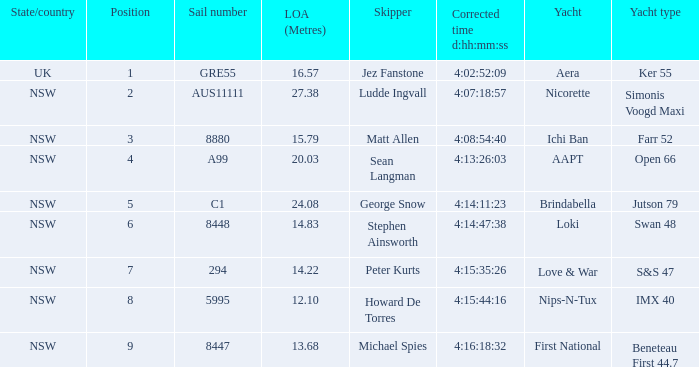How is the nsw open 66 racing boat ranked? 4.0. 